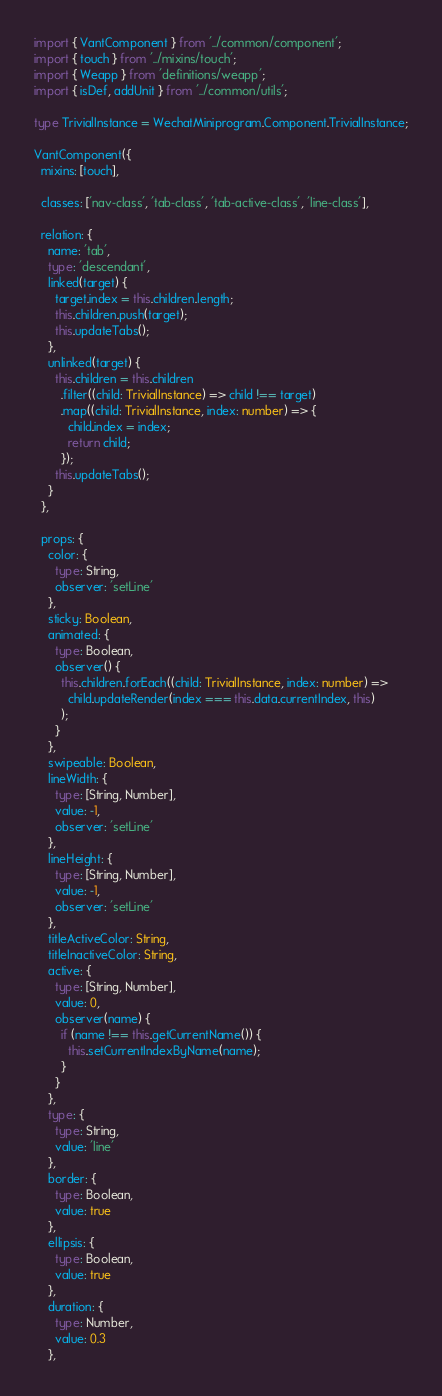Convert code to text. <code><loc_0><loc_0><loc_500><loc_500><_TypeScript_>import { VantComponent } from '../common/component';
import { touch } from '../mixins/touch';
import { Weapp } from 'definitions/weapp';
import { isDef, addUnit } from '../common/utils';

type TrivialInstance = WechatMiniprogram.Component.TrivialInstance;

VantComponent({
  mixins: [touch],

  classes: ['nav-class', 'tab-class', 'tab-active-class', 'line-class'],

  relation: {
    name: 'tab',
    type: 'descendant',
    linked(target) {
      target.index = this.children.length;
      this.children.push(target);
      this.updateTabs();
    },
    unlinked(target) {
      this.children = this.children
        .filter((child: TrivialInstance) => child !== target)
        .map((child: TrivialInstance, index: number) => {
          child.index = index;
          return child;
        });
      this.updateTabs();
    }
  },

  props: {
    color: {
      type: String,
      observer: 'setLine'
    },
    sticky: Boolean,
    animated: {
      type: Boolean,
      observer() {
        this.children.forEach((child: TrivialInstance, index: number) =>
          child.updateRender(index === this.data.currentIndex, this)
        );
      }
    },
    swipeable: Boolean,
    lineWidth: {
      type: [String, Number],
      value: -1,
      observer: 'setLine'
    },
    lineHeight: {
      type: [String, Number],
      value: -1,
      observer: 'setLine'
    },
    titleActiveColor: String,
    titleInactiveColor: String,
    active: {
      type: [String, Number],
      value: 0,
      observer(name) {
        if (name !== this.getCurrentName()) {
          this.setCurrentIndexByName(name);
        }
      }
    },
    type: {
      type: String,
      value: 'line'
    },
    border: {
      type: Boolean,
      value: true
    },
    ellipsis: {
      type: Boolean,
      value: true
    },
    duration: {
      type: Number,
      value: 0.3
    },</code> 